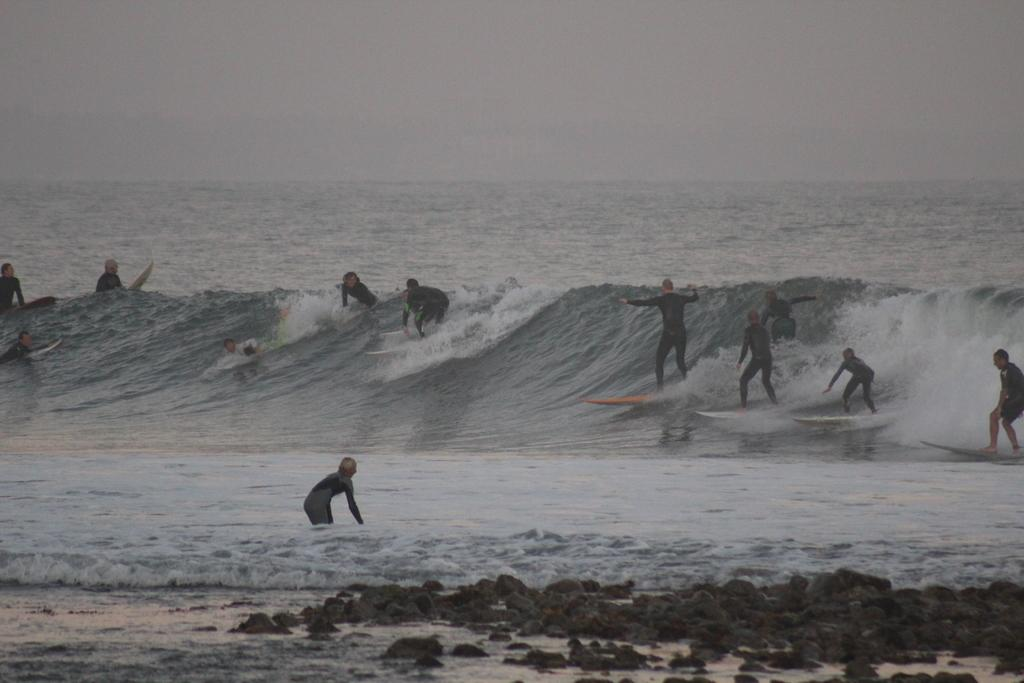What activity are the people in the image engaged in? The people in the image are surfing. Where is the water located in the image? The water appears to be in the sea. What is visible at the top of the image? The sky is visible at the top of the image. What type of terrain is present at the bottom of the image? Stones are present at the bottom of the image. Can you tell me how many forks are visible in the image? There are no forks present in the image; it features people surfing in the sea. Is there an umbrella being used by the surfers in the image? There is no umbrella present in the image; the surfers are in the water and not using any umbrellas. 